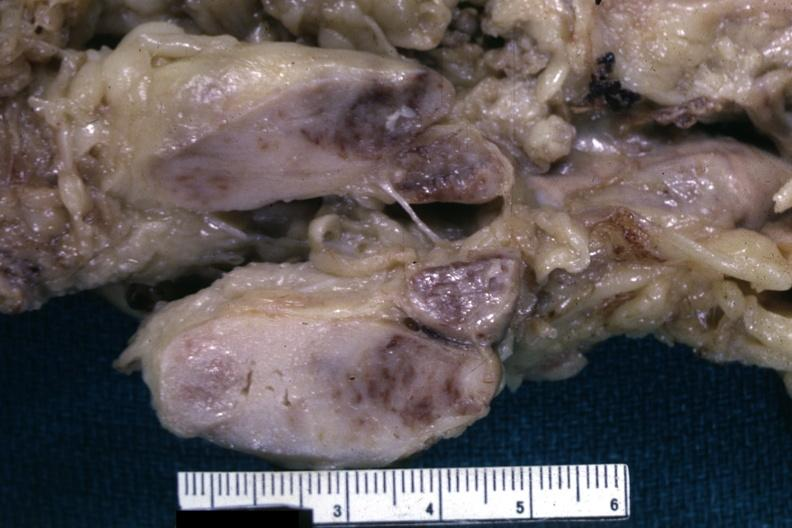what cut surface of nodes shows infiltrative lesion quite well and does not show matting history of this case is unknown could have been a seminoma see other slides?
Answer the question using a single word or phrase. This fixed tissue 